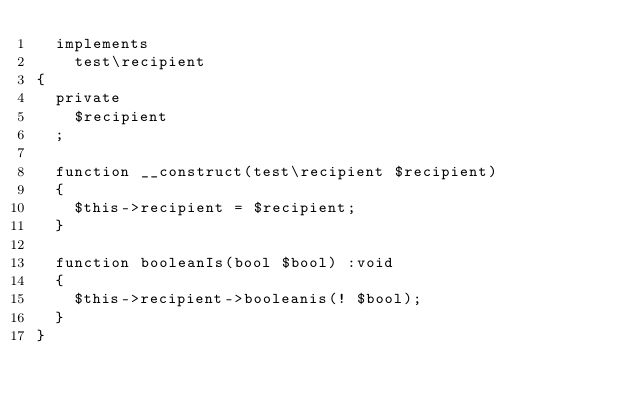Convert code to text. <code><loc_0><loc_0><loc_500><loc_500><_PHP_>	implements
		test\recipient
{
	private
		$recipient
	;

	function __construct(test\recipient $recipient)
	{
		$this->recipient = $recipient;
	}

	function booleanIs(bool $bool) :void
	{
		$this->recipient->booleanis(! $bool);
	}
}
</code> 